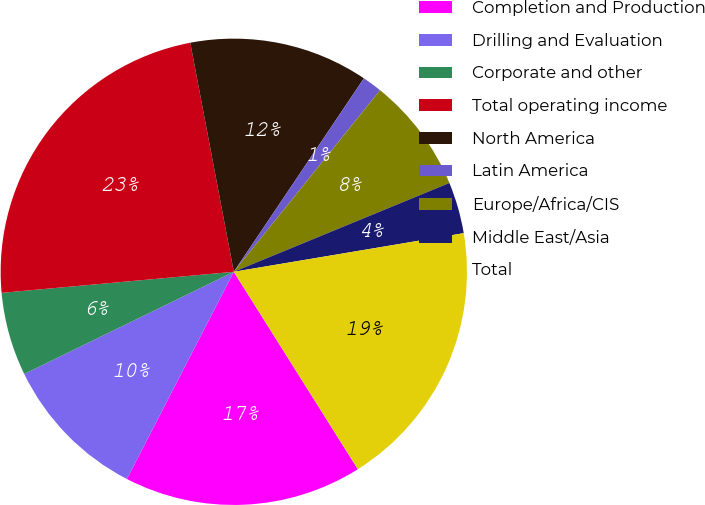Convert chart to OTSL. <chart><loc_0><loc_0><loc_500><loc_500><pie_chart><fcel>Completion and Production<fcel>Drilling and Evaluation<fcel>Corporate and other<fcel>Total operating income<fcel>North America<fcel>Latin America<fcel>Europe/Africa/CIS<fcel>Middle East/Asia<fcel>Total<nl><fcel>16.51%<fcel>10.2%<fcel>5.78%<fcel>23.45%<fcel>12.41%<fcel>1.37%<fcel>7.99%<fcel>3.57%<fcel>18.72%<nl></chart> 